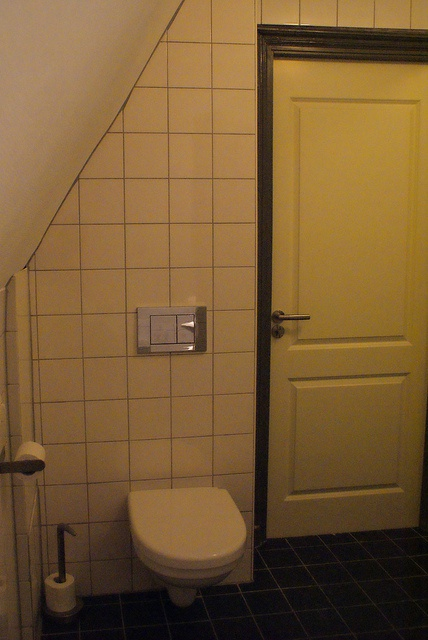Describe the objects in this image and their specific colors. I can see a toilet in tan, black, gray, olive, and maroon tones in this image. 